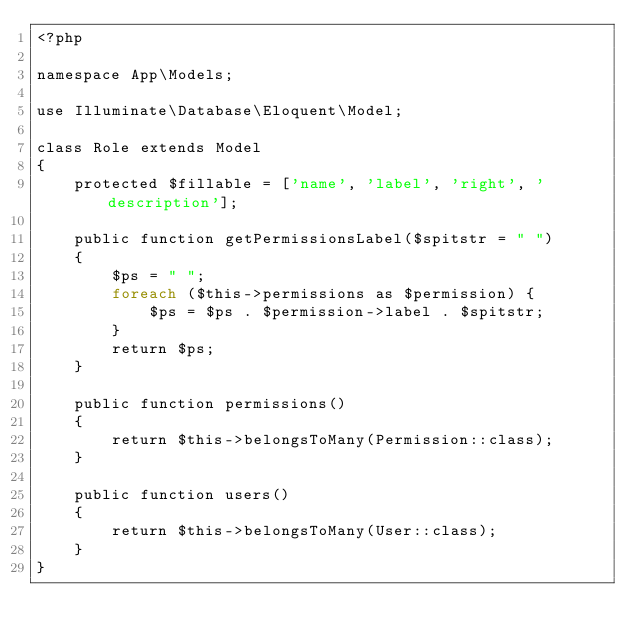<code> <loc_0><loc_0><loc_500><loc_500><_PHP_><?php

namespace App\Models;

use Illuminate\Database\Eloquent\Model;

class Role extends Model
{
    protected $fillable = ['name', 'label', 'right', 'description'];

    public function getPermissionsLabel($spitstr = " ")
    {
        $ps = " ";
        foreach ($this->permissions as $permission) {
            $ps = $ps . $permission->label . $spitstr;
        }
        return $ps;
    }

    public function permissions()
    {
        return $this->belongsToMany(Permission::class);
    }

    public function users()
    {
        return $this->belongsToMany(User::class);
    }
}
</code> 